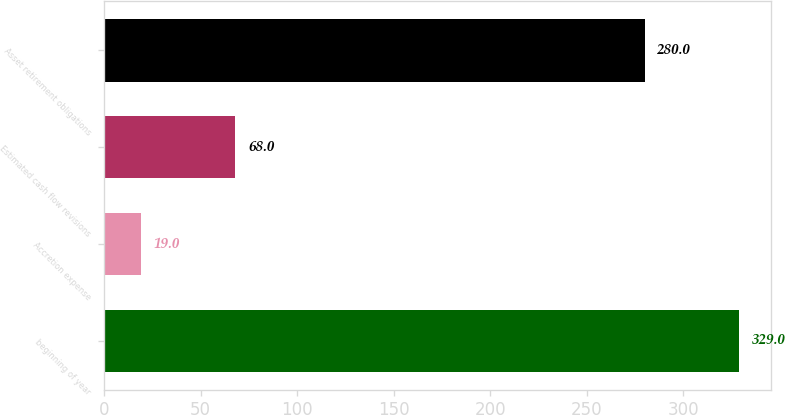Convert chart to OTSL. <chart><loc_0><loc_0><loc_500><loc_500><bar_chart><fcel>beginning of year<fcel>Accretion expense<fcel>Estimated cash flow revisions<fcel>Asset retirement obligations<nl><fcel>329<fcel>19<fcel>68<fcel>280<nl></chart> 